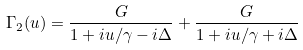<formula> <loc_0><loc_0><loc_500><loc_500>\Gamma _ { 2 } ( u ) = \frac { G } { 1 + i u / \gamma - i \Delta } + \frac { G } { 1 + i u / \gamma + i \Delta }</formula> 